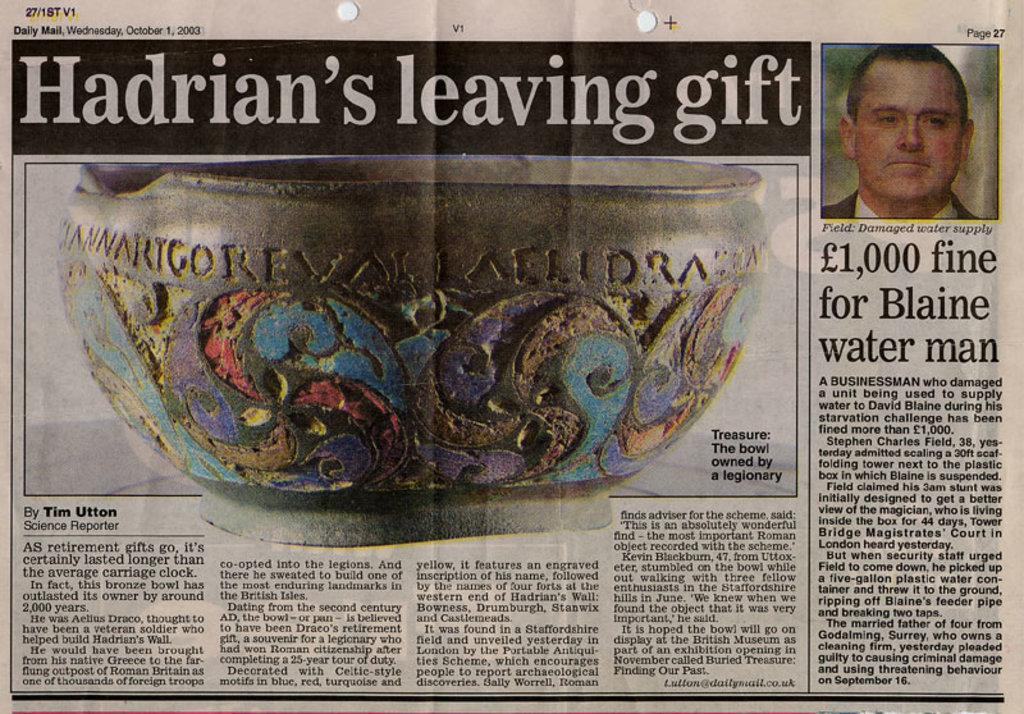What is the main subject of the image? There is a man in the image. What object is also visible in the image? There is a bowl in the image. Are there any words or letters in the image? Yes, there is text in the image. What type of jam is being used to design the man's outfit in the image? There is no jam present in the image, nor is there any indication that the man's outfit is being designed. 